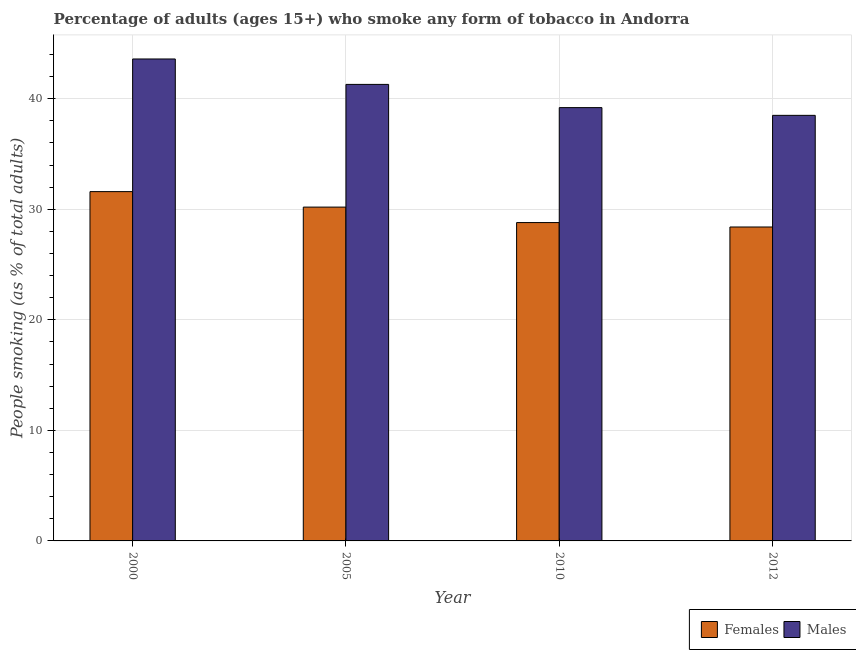Are the number of bars per tick equal to the number of legend labels?
Offer a terse response. Yes. What is the percentage of males who smoke in 2000?
Offer a terse response. 43.6. Across all years, what is the maximum percentage of males who smoke?
Your answer should be very brief. 43.6. Across all years, what is the minimum percentage of females who smoke?
Offer a terse response. 28.4. What is the total percentage of females who smoke in the graph?
Give a very brief answer. 119. What is the difference between the percentage of males who smoke in 2000 and that in 2012?
Give a very brief answer. 5.1. What is the difference between the percentage of males who smoke in 2005 and the percentage of females who smoke in 2010?
Ensure brevity in your answer.  2.1. What is the average percentage of females who smoke per year?
Your answer should be compact. 29.75. In the year 2012, what is the difference between the percentage of males who smoke and percentage of females who smoke?
Give a very brief answer. 0. In how many years, is the percentage of females who smoke greater than 28 %?
Provide a short and direct response. 4. What is the ratio of the percentage of females who smoke in 2010 to that in 2012?
Provide a short and direct response. 1.01. Is the difference between the percentage of females who smoke in 2005 and 2010 greater than the difference between the percentage of males who smoke in 2005 and 2010?
Give a very brief answer. No. What is the difference between the highest and the second highest percentage of females who smoke?
Offer a terse response. 1.4. What is the difference between the highest and the lowest percentage of males who smoke?
Give a very brief answer. 5.1. In how many years, is the percentage of males who smoke greater than the average percentage of males who smoke taken over all years?
Your answer should be very brief. 2. Is the sum of the percentage of females who smoke in 2000 and 2012 greater than the maximum percentage of males who smoke across all years?
Offer a terse response. Yes. What does the 1st bar from the left in 2000 represents?
Your answer should be very brief. Females. What does the 1st bar from the right in 2012 represents?
Offer a very short reply. Males. Are all the bars in the graph horizontal?
Give a very brief answer. No. How many years are there in the graph?
Ensure brevity in your answer.  4. What is the difference between two consecutive major ticks on the Y-axis?
Offer a terse response. 10. Are the values on the major ticks of Y-axis written in scientific E-notation?
Provide a succinct answer. No. Does the graph contain any zero values?
Ensure brevity in your answer.  No. Does the graph contain grids?
Provide a succinct answer. Yes. How are the legend labels stacked?
Ensure brevity in your answer.  Horizontal. What is the title of the graph?
Offer a very short reply. Percentage of adults (ages 15+) who smoke any form of tobacco in Andorra. What is the label or title of the X-axis?
Give a very brief answer. Year. What is the label or title of the Y-axis?
Your answer should be very brief. People smoking (as % of total adults). What is the People smoking (as % of total adults) in Females in 2000?
Your answer should be compact. 31.6. What is the People smoking (as % of total adults) of Males in 2000?
Provide a short and direct response. 43.6. What is the People smoking (as % of total adults) in Females in 2005?
Ensure brevity in your answer.  30.2. What is the People smoking (as % of total adults) in Males in 2005?
Ensure brevity in your answer.  41.3. What is the People smoking (as % of total adults) in Females in 2010?
Keep it short and to the point. 28.8. What is the People smoking (as % of total adults) in Males in 2010?
Give a very brief answer. 39.2. What is the People smoking (as % of total adults) of Females in 2012?
Your answer should be very brief. 28.4. What is the People smoking (as % of total adults) in Males in 2012?
Your answer should be very brief. 38.5. Across all years, what is the maximum People smoking (as % of total adults) in Females?
Your answer should be very brief. 31.6. Across all years, what is the maximum People smoking (as % of total adults) in Males?
Make the answer very short. 43.6. Across all years, what is the minimum People smoking (as % of total adults) of Females?
Make the answer very short. 28.4. Across all years, what is the minimum People smoking (as % of total adults) in Males?
Give a very brief answer. 38.5. What is the total People smoking (as % of total adults) of Females in the graph?
Your answer should be very brief. 119. What is the total People smoking (as % of total adults) of Males in the graph?
Offer a very short reply. 162.6. What is the difference between the People smoking (as % of total adults) of Females in 2000 and that in 2005?
Provide a short and direct response. 1.4. What is the difference between the People smoking (as % of total adults) in Females in 2000 and that in 2012?
Your answer should be very brief. 3.2. What is the difference between the People smoking (as % of total adults) in Females in 2005 and that in 2010?
Offer a very short reply. 1.4. What is the difference between the People smoking (as % of total adults) in Males in 2005 and that in 2010?
Make the answer very short. 2.1. What is the difference between the People smoking (as % of total adults) of Females in 2005 and that in 2012?
Offer a very short reply. 1.8. What is the difference between the People smoking (as % of total adults) in Females in 2000 and the People smoking (as % of total adults) in Males in 2010?
Ensure brevity in your answer.  -7.6. What is the difference between the People smoking (as % of total adults) in Females in 2000 and the People smoking (as % of total adults) in Males in 2012?
Your response must be concise. -6.9. What is the difference between the People smoking (as % of total adults) in Females in 2005 and the People smoking (as % of total adults) in Males in 2010?
Your response must be concise. -9. What is the difference between the People smoking (as % of total adults) of Females in 2005 and the People smoking (as % of total adults) of Males in 2012?
Provide a succinct answer. -8.3. What is the difference between the People smoking (as % of total adults) of Females in 2010 and the People smoking (as % of total adults) of Males in 2012?
Offer a very short reply. -9.7. What is the average People smoking (as % of total adults) in Females per year?
Your response must be concise. 29.75. What is the average People smoking (as % of total adults) in Males per year?
Keep it short and to the point. 40.65. In the year 2005, what is the difference between the People smoking (as % of total adults) in Females and People smoking (as % of total adults) in Males?
Give a very brief answer. -11.1. In the year 2010, what is the difference between the People smoking (as % of total adults) in Females and People smoking (as % of total adults) in Males?
Keep it short and to the point. -10.4. In the year 2012, what is the difference between the People smoking (as % of total adults) in Females and People smoking (as % of total adults) in Males?
Keep it short and to the point. -10.1. What is the ratio of the People smoking (as % of total adults) in Females in 2000 to that in 2005?
Your answer should be very brief. 1.05. What is the ratio of the People smoking (as % of total adults) in Males in 2000 to that in 2005?
Make the answer very short. 1.06. What is the ratio of the People smoking (as % of total adults) in Females in 2000 to that in 2010?
Provide a succinct answer. 1.1. What is the ratio of the People smoking (as % of total adults) in Males in 2000 to that in 2010?
Keep it short and to the point. 1.11. What is the ratio of the People smoking (as % of total adults) of Females in 2000 to that in 2012?
Ensure brevity in your answer.  1.11. What is the ratio of the People smoking (as % of total adults) of Males in 2000 to that in 2012?
Offer a very short reply. 1.13. What is the ratio of the People smoking (as % of total adults) of Females in 2005 to that in 2010?
Your response must be concise. 1.05. What is the ratio of the People smoking (as % of total adults) in Males in 2005 to that in 2010?
Provide a short and direct response. 1.05. What is the ratio of the People smoking (as % of total adults) in Females in 2005 to that in 2012?
Your answer should be very brief. 1.06. What is the ratio of the People smoking (as % of total adults) of Males in 2005 to that in 2012?
Provide a succinct answer. 1.07. What is the ratio of the People smoking (as % of total adults) of Females in 2010 to that in 2012?
Provide a short and direct response. 1.01. What is the ratio of the People smoking (as % of total adults) in Males in 2010 to that in 2012?
Your response must be concise. 1.02. What is the difference between the highest and the second highest People smoking (as % of total adults) in Females?
Offer a very short reply. 1.4. What is the difference between the highest and the second highest People smoking (as % of total adults) of Males?
Your answer should be compact. 2.3. What is the difference between the highest and the lowest People smoking (as % of total adults) of Females?
Offer a very short reply. 3.2. What is the difference between the highest and the lowest People smoking (as % of total adults) of Males?
Your answer should be compact. 5.1. 